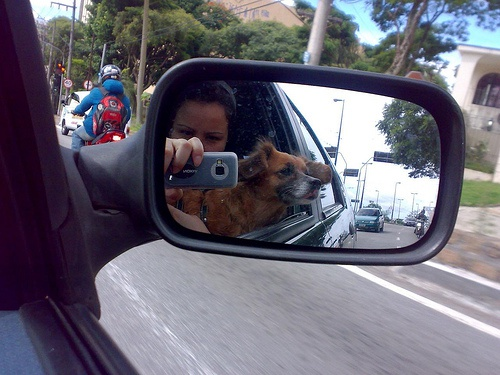Describe the objects in this image and their specific colors. I can see car in navy, black, maroon, and gray tones, dog in navy, black, maroon, and gray tones, people in navy, black, maroon, brown, and darkgray tones, cell phone in navy, black, gray, and darkblue tones, and people in navy, blue, and gray tones in this image. 